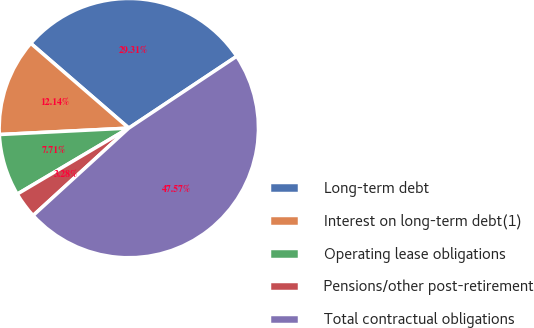Convert chart to OTSL. <chart><loc_0><loc_0><loc_500><loc_500><pie_chart><fcel>Long-term debt<fcel>Interest on long-term debt(1)<fcel>Operating lease obligations<fcel>Pensions/other post-retirement<fcel>Total contractual obligations<nl><fcel>29.31%<fcel>12.14%<fcel>7.71%<fcel>3.28%<fcel>47.57%<nl></chart> 